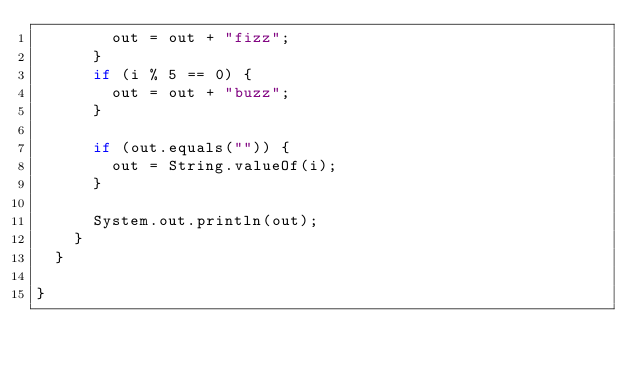<code> <loc_0><loc_0><loc_500><loc_500><_Java_>        out = out + "fizz";
      }
      if (i % 5 == 0) {
        out = out + "buzz";
      }

      if (out.equals("")) {
        out = String.valueOf(i);
      }

      System.out.println(out);
    }
  }

}
</code> 